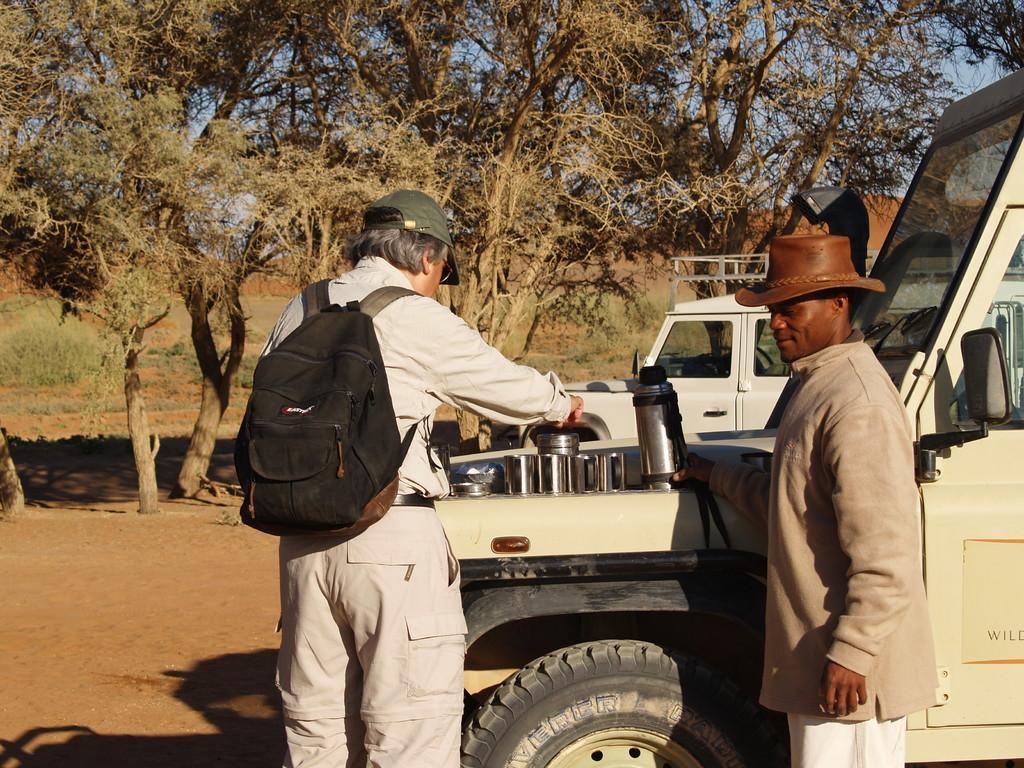Can you describe this image briefly? In this image i can see 2 persons wearing hats, the person on the left side is wearing a bag, and holding a jar in his hand. In the background i can see few vehicles, trees, grass and sky. 